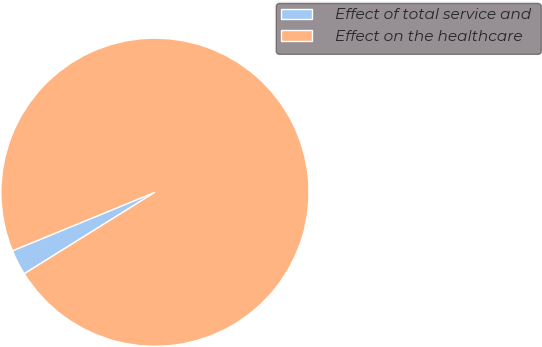Convert chart. <chart><loc_0><loc_0><loc_500><loc_500><pie_chart><fcel>Effect of total service and<fcel>Effect on the healthcare<nl><fcel>2.67%<fcel>97.33%<nl></chart> 